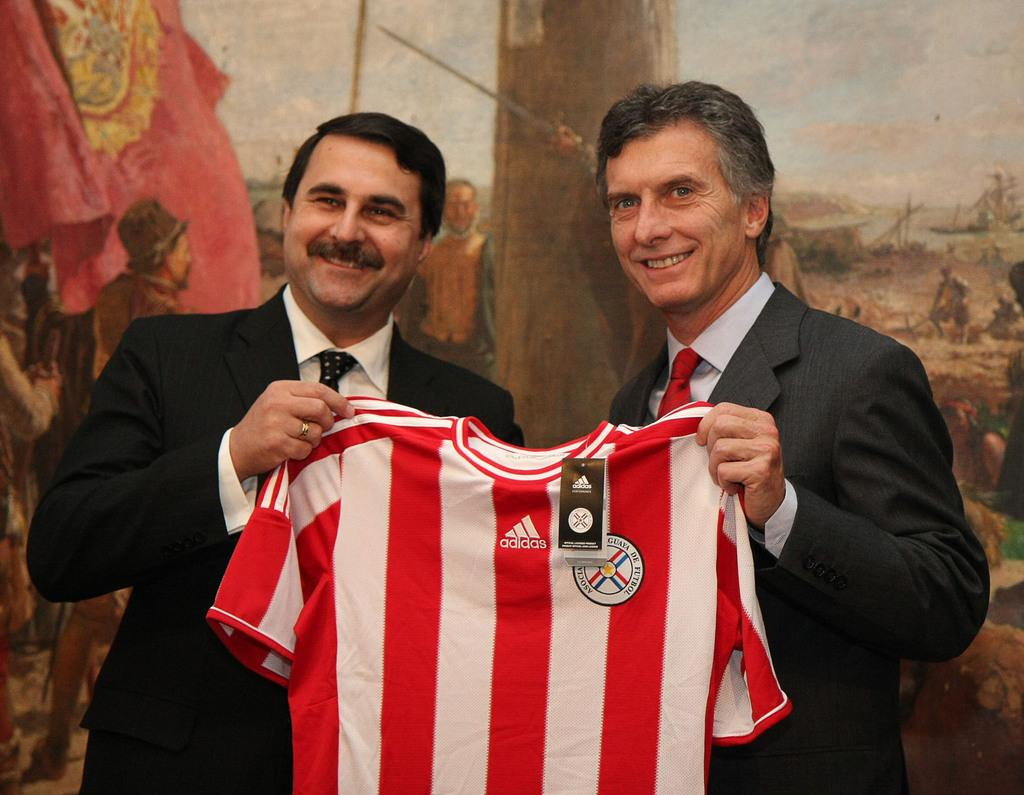<image>
Give a short and clear explanation of the subsequent image. Two men wearing suits hold a red and white striped Adidas jersey in front of a large painting. 